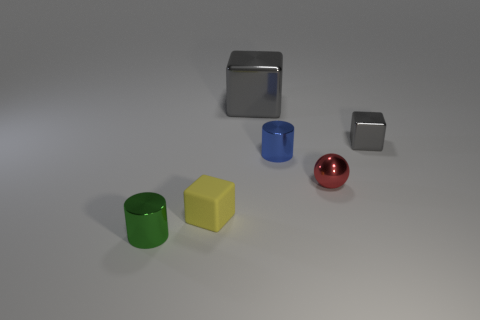Is the green object the same size as the red sphere?
Give a very brief answer. Yes. There is a cylinder that is to the right of the gray metal block behind the gray metal object that is on the right side of the big gray metal cube; what color is it?
Your answer should be very brief. Blue. What number of tiny metal blocks are the same color as the large metal object?
Give a very brief answer. 1. How many small things are cylinders or metallic balls?
Make the answer very short. 3. Is there a tiny gray thing that has the same shape as the big metallic object?
Your response must be concise. Yes. Does the tiny green metallic object have the same shape as the yellow rubber object?
Give a very brief answer. No. There is a tiny cube that is behind the tiny metal cylinder that is behind the green metallic cylinder; what color is it?
Give a very brief answer. Gray. What is the color of the metallic cube that is the same size as the red metal object?
Your response must be concise. Gray. What number of metal things are yellow things or tiny cylinders?
Your answer should be very brief. 2. There is a yellow cube that is left of the small sphere; how many tiny shiny objects are in front of it?
Keep it short and to the point. 1. 